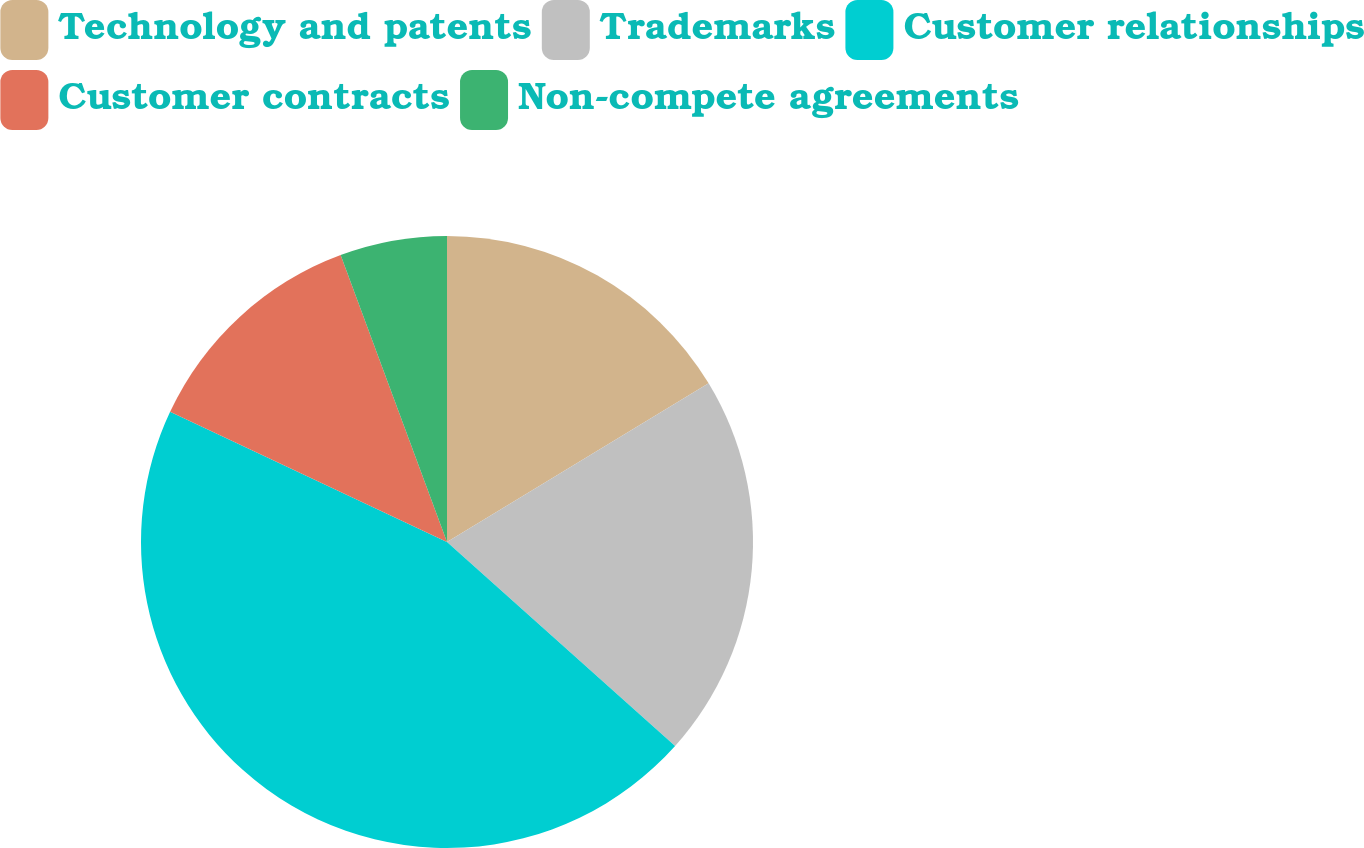<chart> <loc_0><loc_0><loc_500><loc_500><pie_chart><fcel>Technology and patents<fcel>Trademarks<fcel>Customer relationships<fcel>Customer contracts<fcel>Non-compete agreements<nl><fcel>16.32%<fcel>20.29%<fcel>45.38%<fcel>12.35%<fcel>5.65%<nl></chart> 